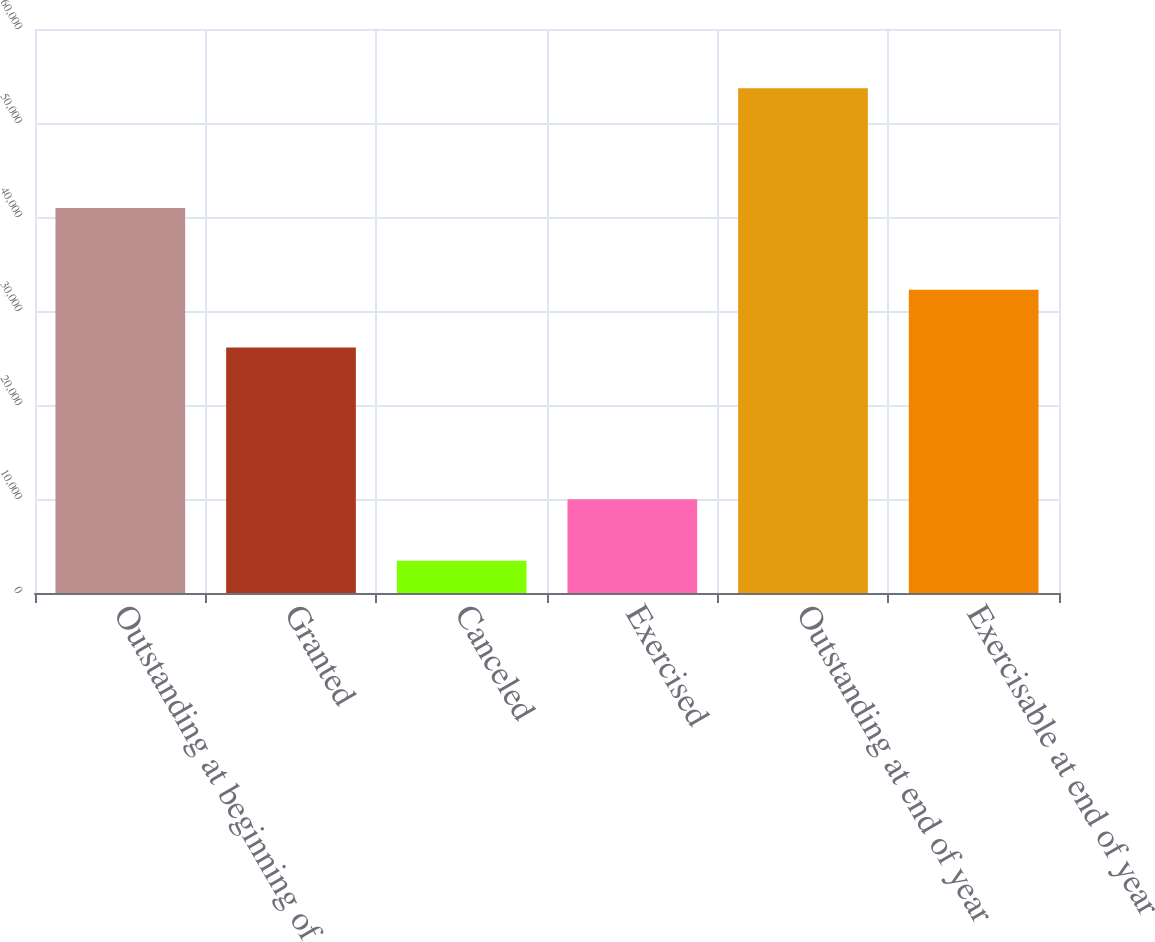Convert chart to OTSL. <chart><loc_0><loc_0><loc_500><loc_500><bar_chart><fcel>Outstanding at beginning of<fcel>Granted<fcel>Canceled<fcel>Exercised<fcel>Outstanding at end of year<fcel>Exercisable at end of year<nl><fcel>40969<fcel>26121<fcel>3425<fcel>9981<fcel>53684<fcel>32250<nl></chart> 